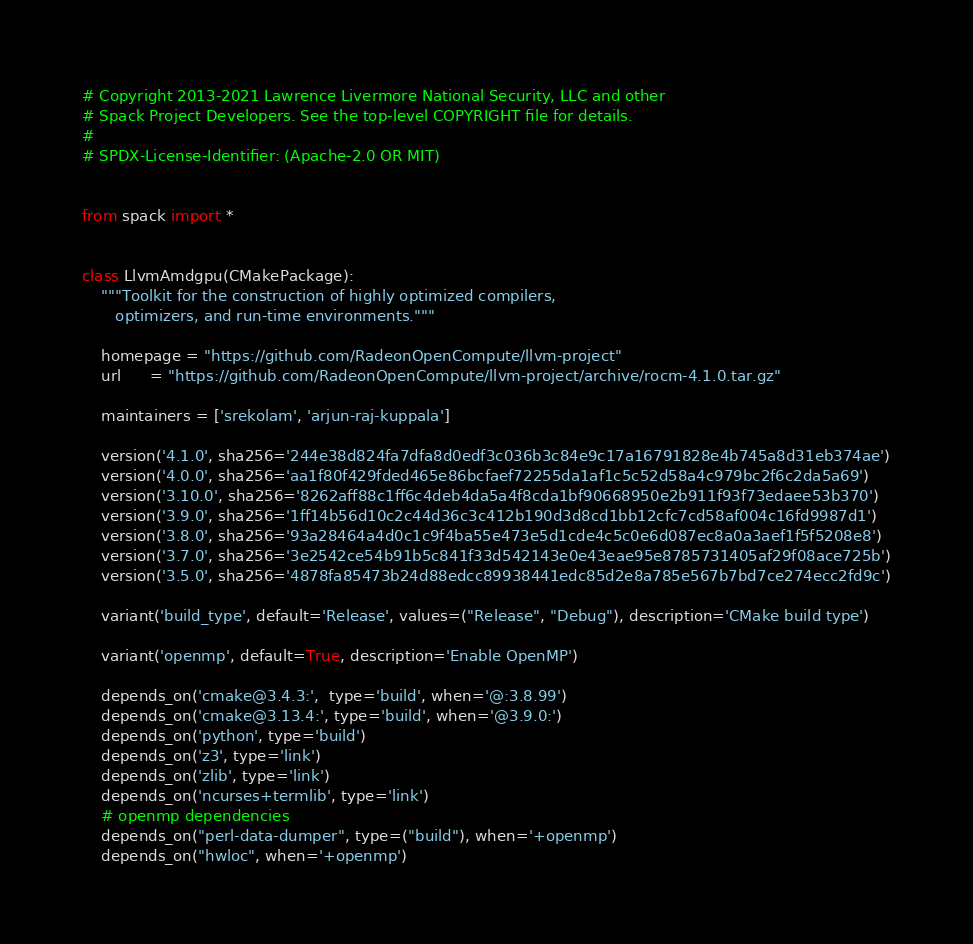<code> <loc_0><loc_0><loc_500><loc_500><_Python_># Copyright 2013-2021 Lawrence Livermore National Security, LLC and other
# Spack Project Developers. See the top-level COPYRIGHT file for details.
#
# SPDX-License-Identifier: (Apache-2.0 OR MIT)


from spack import *


class LlvmAmdgpu(CMakePackage):
    """Toolkit for the construction of highly optimized compilers,
       optimizers, and run-time environments."""

    homepage = "https://github.com/RadeonOpenCompute/llvm-project"
    url      = "https://github.com/RadeonOpenCompute/llvm-project/archive/rocm-4.1.0.tar.gz"

    maintainers = ['srekolam', 'arjun-raj-kuppala']

    version('4.1.0', sha256='244e38d824fa7dfa8d0edf3c036b3c84e9c17a16791828e4b745a8d31eb374ae')
    version('4.0.0', sha256='aa1f80f429fded465e86bcfaef72255da1af1c5c52d58a4c979bc2f6c2da5a69')
    version('3.10.0', sha256='8262aff88c1ff6c4deb4da5a4f8cda1bf90668950e2b911f93f73edaee53b370')
    version('3.9.0', sha256='1ff14b56d10c2c44d36c3c412b190d3d8cd1bb12cfc7cd58af004c16fd9987d1')
    version('3.8.0', sha256='93a28464a4d0c1c9f4ba55e473e5d1cde4c5c0e6d087ec8a0a3aef1f5f5208e8')
    version('3.7.0', sha256='3e2542ce54b91b5c841f33d542143e0e43eae95e8785731405af29f08ace725b')
    version('3.5.0', sha256='4878fa85473b24d88edcc89938441edc85d2e8a785e567b7bd7ce274ecc2fd9c')

    variant('build_type', default='Release', values=("Release", "Debug"), description='CMake build type')

    variant('openmp', default=True, description='Enable OpenMP')

    depends_on('cmake@3.4.3:',  type='build', when='@:3.8.99')
    depends_on('cmake@3.13.4:', type='build', when='@3.9.0:')
    depends_on('python', type='build')
    depends_on('z3', type='link')
    depends_on('zlib', type='link')
    depends_on('ncurses+termlib', type='link')
    # openmp dependencies
    depends_on("perl-data-dumper", type=("build"), when='+openmp')
    depends_on("hwloc", when='+openmp')</code> 